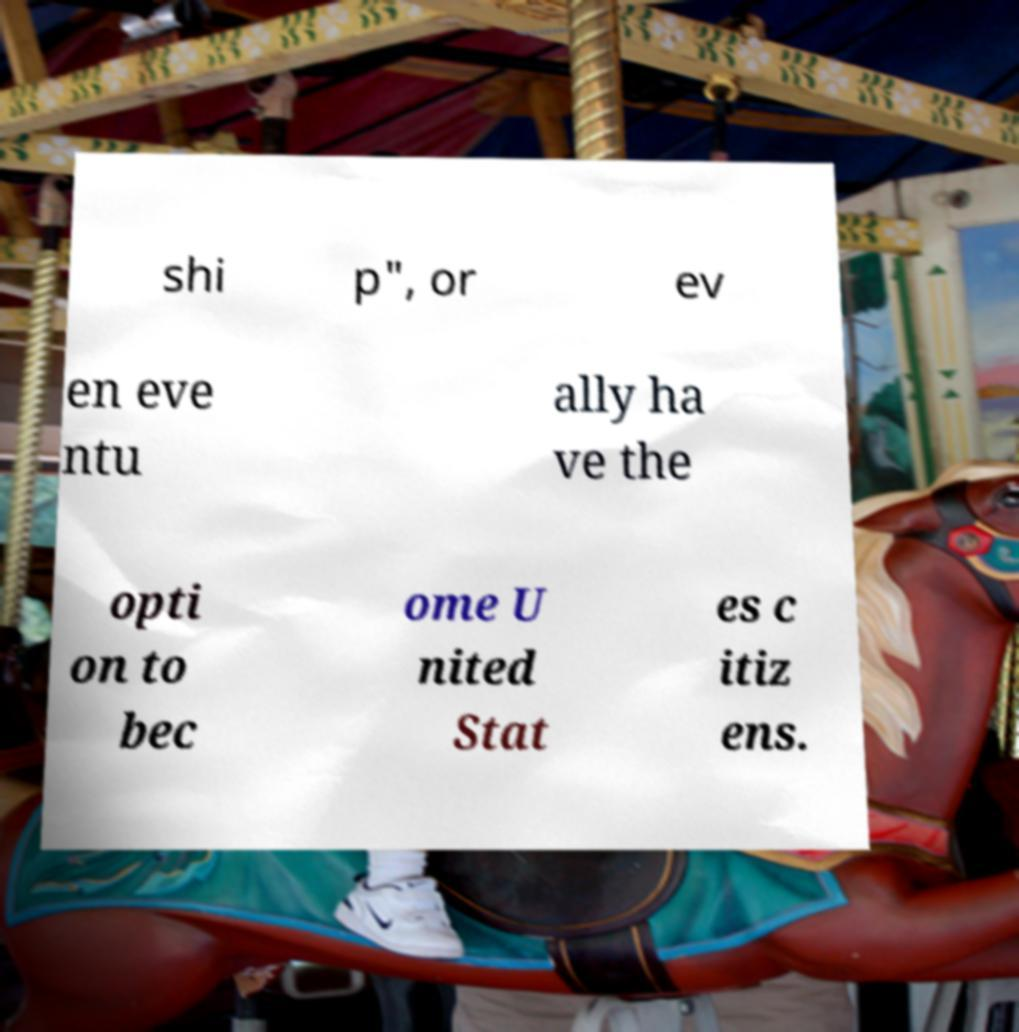For documentation purposes, I need the text within this image transcribed. Could you provide that? shi p", or ev en eve ntu ally ha ve the opti on to bec ome U nited Stat es c itiz ens. 